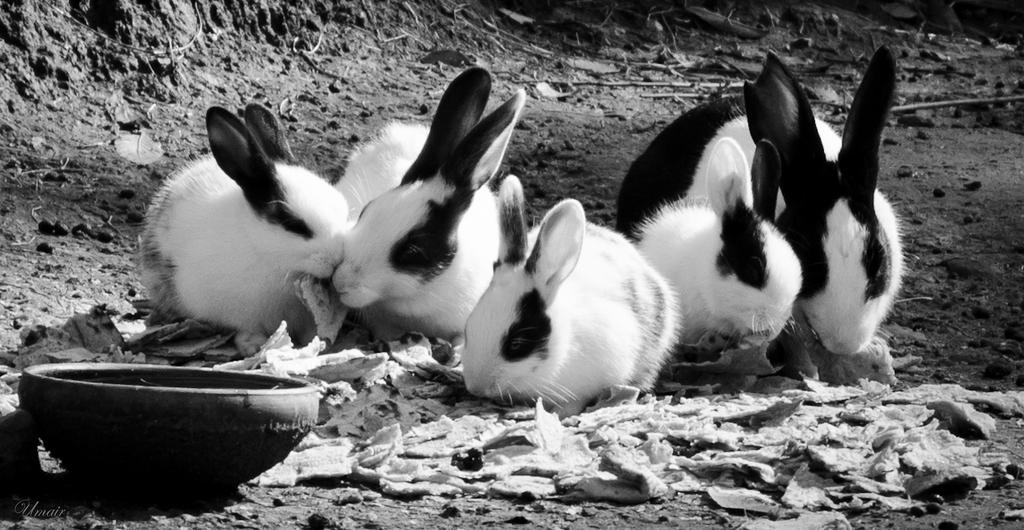What is located in the front of the image? There is a bowl in the front of the image. What animals are in the center of the image? There are rabbits in the center of the image. What can be seen on the ground in the background of the image? There are dry leaves on the ground in the background of the image. What type of coat is the rabbit wearing in the image? There are no rabbits wearing coats in the image; the rabbits are not wearing any clothing. How does the image start? The image does not have a beginning or end; it is a static representation. 